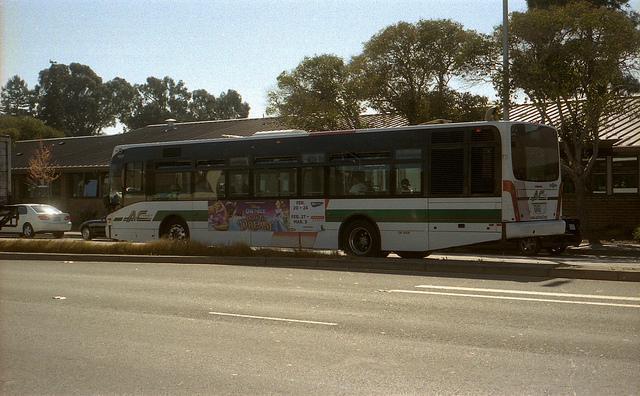What is the bus driving in?
Indicate the correct response by choosing from the four available options to answer the question.
Options: Freeway, emergency lane, hov lane, middle lane. Hov lane. 